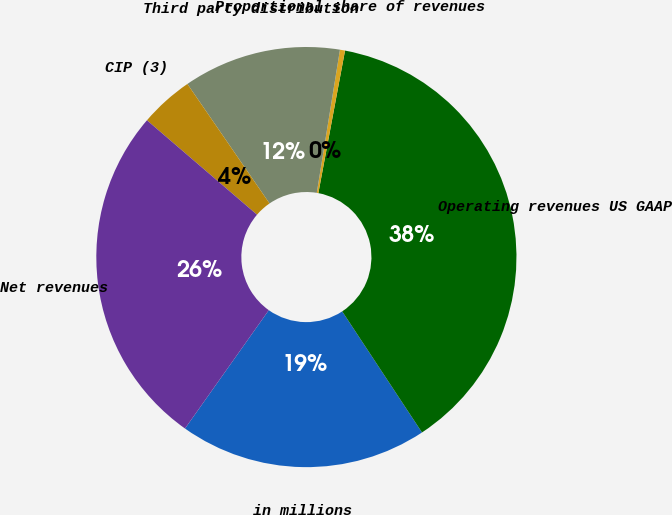Convert chart. <chart><loc_0><loc_0><loc_500><loc_500><pie_chart><fcel>in millions<fcel>Operating revenues US GAAP<fcel>Proportional share of revenues<fcel>Third party distribution<fcel>CIP (3)<fcel>Net revenues<nl><fcel>19.08%<fcel>37.78%<fcel>0.39%<fcel>12.14%<fcel>4.13%<fcel>26.48%<nl></chart> 